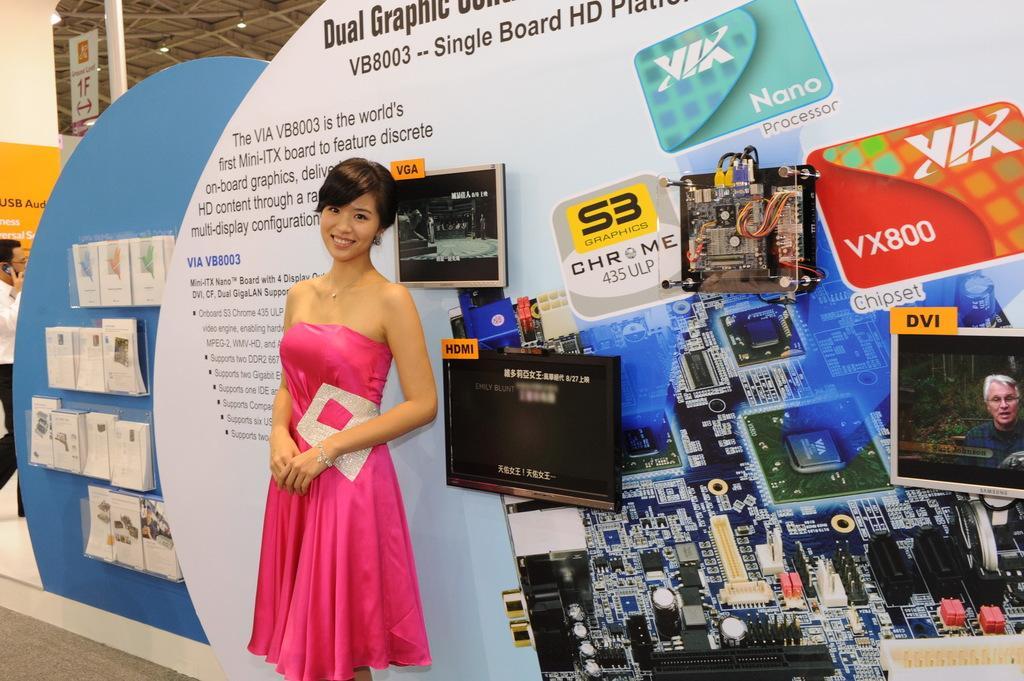Could you give a brief overview of what you see in this image? In this image I can see a person standing. There are televisions attached to the board. In the right side of the image it looks like electronic devices are attached to the board. There are papers , boards and in the left side of the image there is another person. Also there is a roof with lights. 